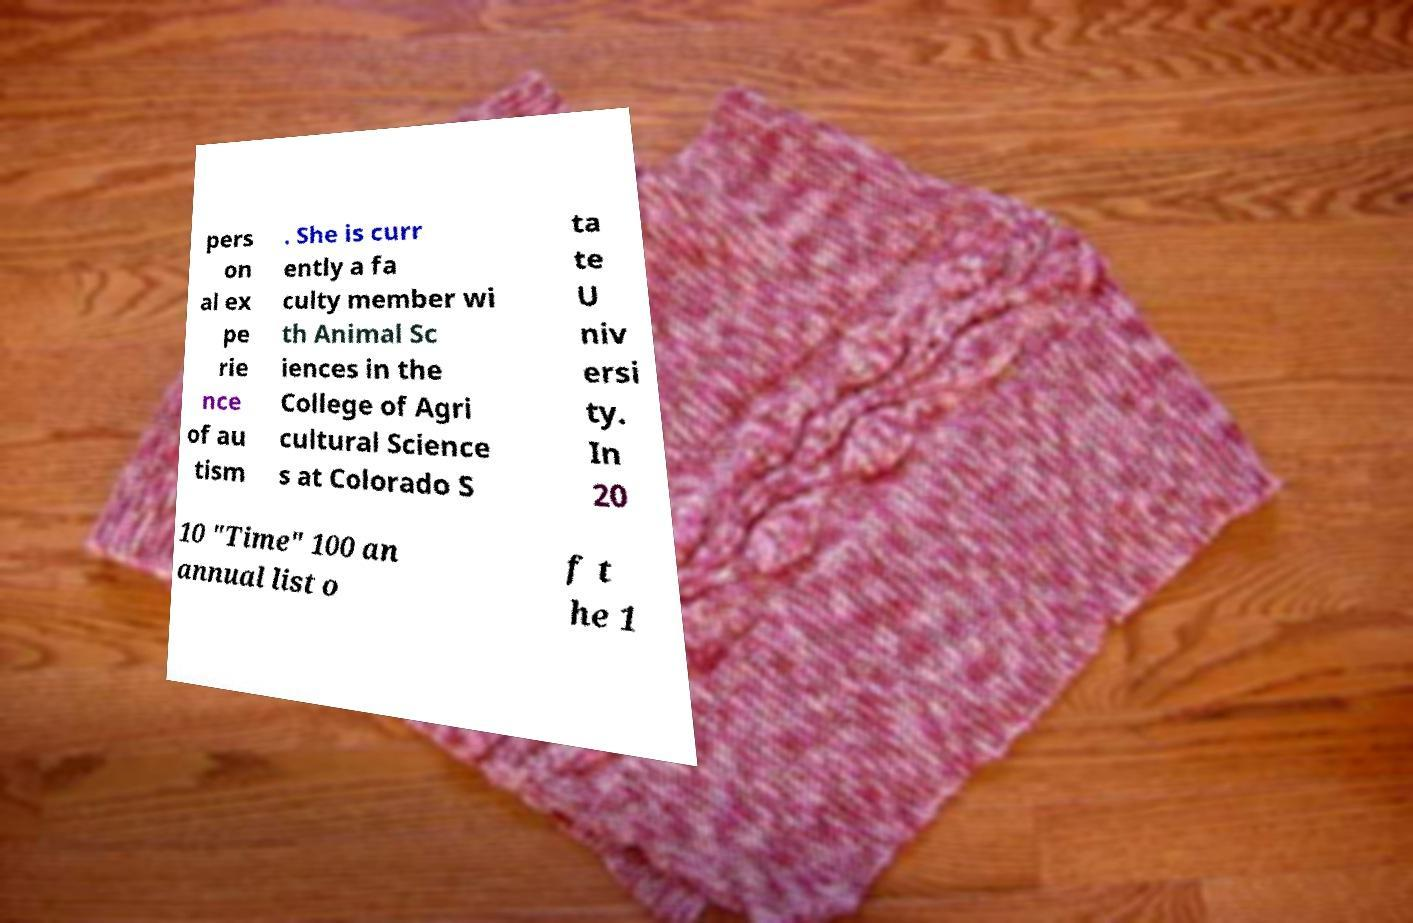I need the written content from this picture converted into text. Can you do that? pers on al ex pe rie nce of au tism . She is curr ently a fa culty member wi th Animal Sc iences in the College of Agri cultural Science s at Colorado S ta te U niv ersi ty. In 20 10 "Time" 100 an annual list o f t he 1 